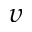<formula> <loc_0><loc_0><loc_500><loc_500>\upsilon</formula> 